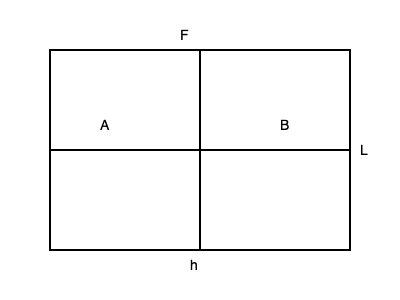As a fashion designer known for avant-garde accessories, you're developing a statement necklace with an oversized pendant. The pendant is a rectangular plate of dimensions $L \times h$, suspended from its center. Given that the material has a yield strength of $\sigma_y$, determine the maximum force $F$ that can be applied at the center before the pendant begins to yield, assuming it behaves like a simply supported beam. To solve this problem, we'll use principles from beam theory in engineering mechanics:

1. The pendant can be modeled as a simply supported beam with a point load at the center.

2. The maximum bending moment $M_{max}$ occurs at the center of the beam and is given by:
   $$M_{max} = \frac{FL}{4}$$

3. The section modulus $Z$ for a rectangular cross-section is:
   $$Z = \frac{bh^2}{6}$$
   where $b$ is the width (thickness) of the pendant.

4. The maximum stress $\sigma_{max}$ in the beam is:
   $$\sigma_{max} = \frac{M_{max}}{Z}$$

5. At the point of yielding, $\sigma_{max} = \sigma_y$. Therefore:
   $$\sigma_y = \frac{M_{max}}{Z} = \frac{FL/4}{bh^2/6}$$

6. Solving for $F$:
   $$F = \frac{4\sigma_y bh^2}{3L}$$

This equation gives the maximum force that can be applied before the pendant begins to yield.
Answer: $F = \frac{4\sigma_y bh^2}{3L}$ 